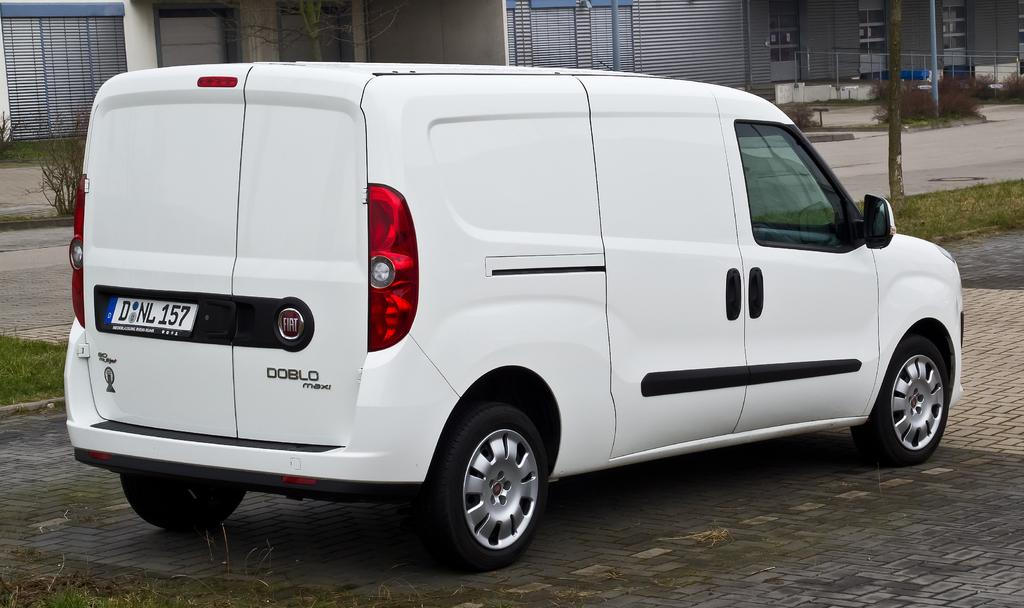<image>
Provide a brief description of the given image. A white DOBLO maxi on bricks created for the road 